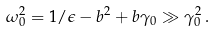<formula> <loc_0><loc_0><loc_500><loc_500>\omega _ { 0 } ^ { 2 } = 1 / \epsilon - b ^ { 2 } + b \gamma _ { 0 } \gg \gamma _ { 0 } ^ { 2 } \, .</formula> 